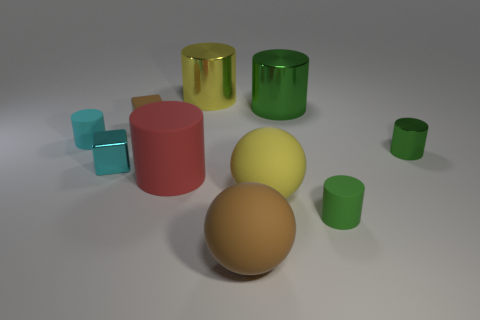Do the small brown object and the large green thing have the same material?
Provide a succinct answer. No. How many other things are the same shape as the cyan matte thing?
Offer a very short reply. 5. There is a cylinder that is behind the small cyan shiny cube and to the left of the yellow cylinder; what size is it?
Your response must be concise. Small. How many metallic objects are either red cylinders or small brown blocks?
Provide a short and direct response. 0. There is a green metallic thing that is in front of the cyan cylinder; does it have the same shape as the large yellow thing in front of the tiny green shiny cylinder?
Offer a very short reply. No. Are there any small cubes that have the same material as the big brown sphere?
Keep it short and to the point. Yes. What is the color of the tiny shiny block?
Offer a terse response. Cyan. There is a sphere that is right of the large brown ball; what is its size?
Give a very brief answer. Large. How many big shiny cylinders have the same color as the large rubber cylinder?
Provide a succinct answer. 0. There is a big metal cylinder on the left side of the yellow rubber object; is there a tiny cyan object that is on the right side of it?
Your response must be concise. No. 